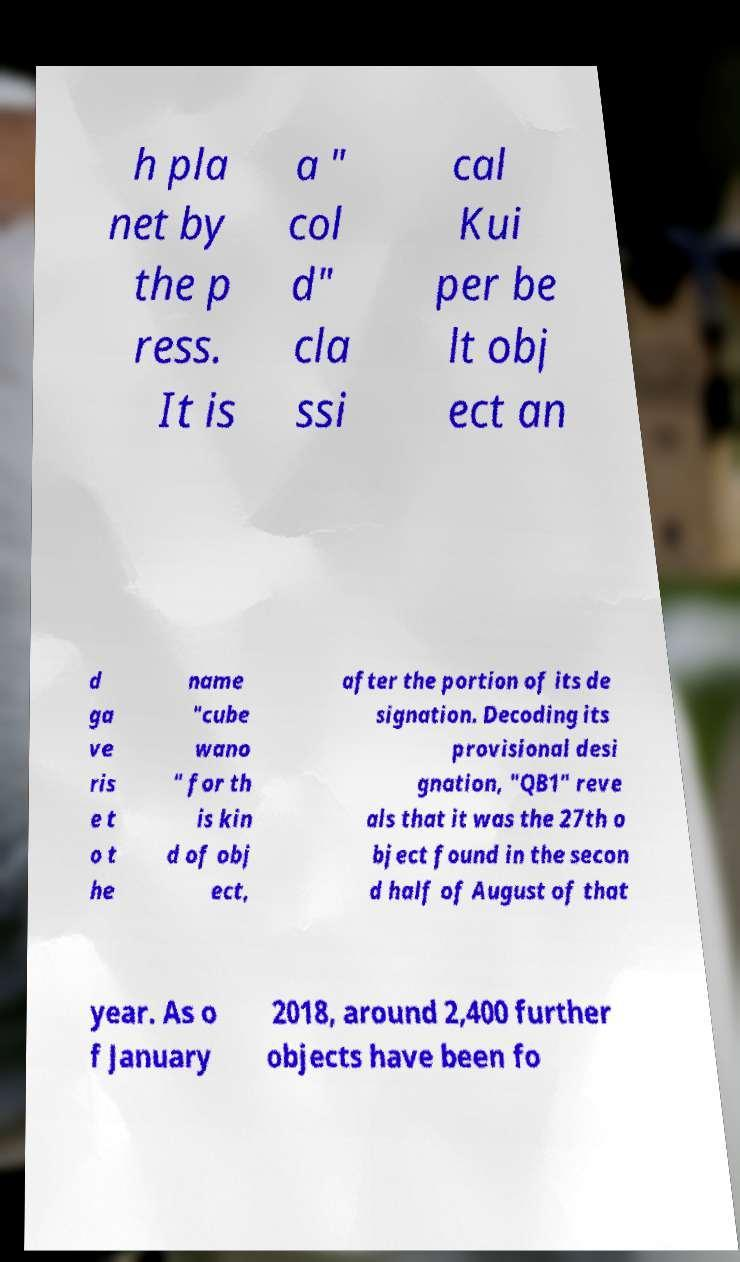I need the written content from this picture converted into text. Can you do that? h pla net by the p ress. It is a " col d" cla ssi cal Kui per be lt obj ect an d ga ve ris e t o t he name "cube wano " for th is kin d of obj ect, after the portion of its de signation. Decoding its provisional desi gnation, "QB1" reve als that it was the 27th o bject found in the secon d half of August of that year. As o f January 2018, around 2,400 further objects have been fo 